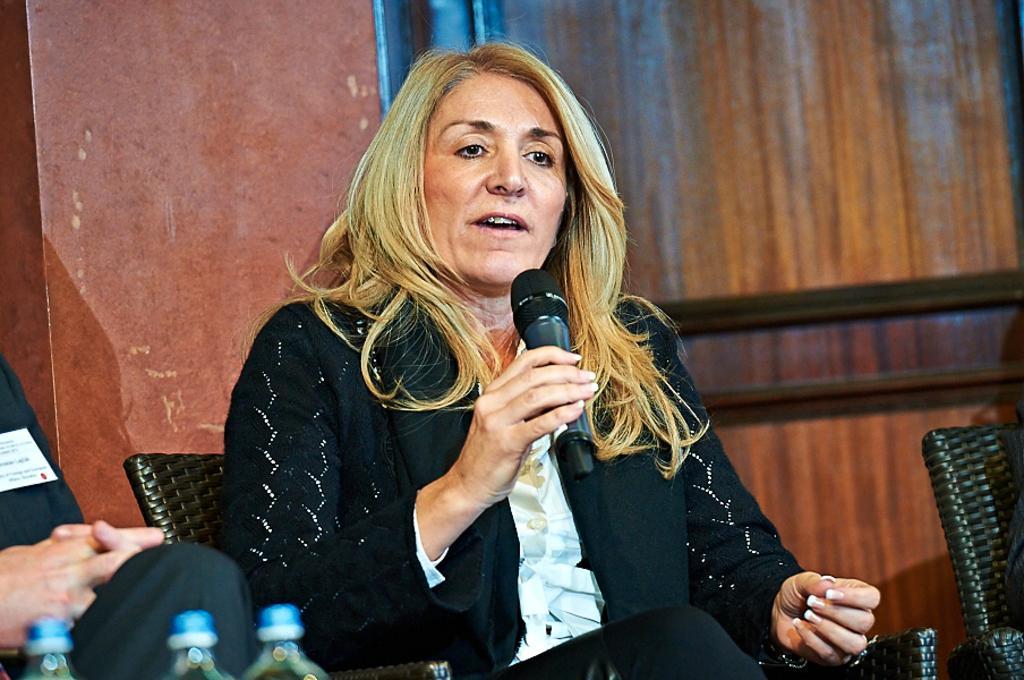How would you summarize this image in a sentence or two? In this image in front there is a person sitting on the chair and she is holding the mike. Beside her there are two other persons sitting on the chairs. In front of them there are bottled waters. Behind them there is a wall. 